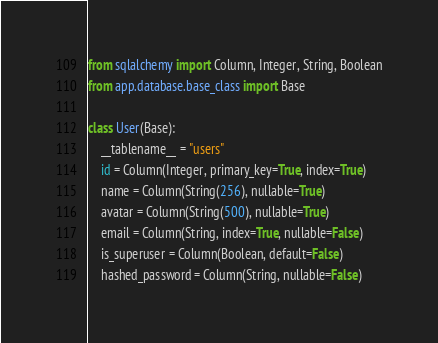<code> <loc_0><loc_0><loc_500><loc_500><_Python_>from sqlalchemy import Column, Integer, String, Boolean
from app.database.base_class import Base

class User(Base):
    __tablename__ = "users"
    id = Column(Integer, primary_key=True, index=True)
    name = Column(String(256), nullable=True)
    avatar = Column(String(500), nullable=True)
    email = Column(String, index=True, nullable=False)
    is_superuser = Column(Boolean, default=False)
    hashed_password = Column(String, nullable=False)</code> 